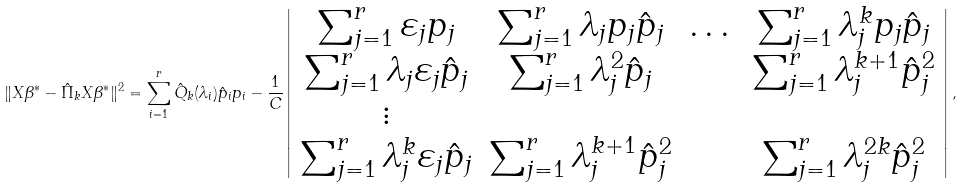<formula> <loc_0><loc_0><loc_500><loc_500>\| X \beta ^ { * } - \hat { \Pi } _ { k } X \beta ^ { * } \| ^ { 2 } = \sum _ { i = 1 } ^ { r } \hat { Q } _ { k } ( \lambda _ { i } ) \hat { p } _ { i } p _ { i } - \frac { 1 } { C } \left | \begin{array} { c c c c } \sum _ { j = 1 } ^ { r } \varepsilon _ { j } p _ { j } & \sum _ { j = 1 } ^ { r } \lambda _ { j } p _ { j } \hat { p } _ { j } & \dots & \sum _ { j = 1 } ^ { r } \lambda _ { j } ^ { k } p _ { j } \hat { p } _ { j } \\ \sum _ { j = 1 } ^ { r } \lambda _ { j } \varepsilon _ { j } \hat { p } _ { j } & \sum _ { j = 1 } ^ { r } \lambda _ { j } ^ { 2 } \hat { p } _ { j } & & \sum _ { j = 1 } ^ { r } \lambda _ { j } ^ { k + 1 } \hat { p } _ { j } ^ { 2 } \\ \vdots & & & \\ \sum _ { j = 1 } ^ { r } \lambda _ { j } ^ { k } \varepsilon _ { j } \hat { p } _ { j } & \sum _ { j = 1 } ^ { r } \lambda _ { j } ^ { k + 1 } \hat { p } _ { j } ^ { 2 } & & \sum _ { j = 1 } ^ { r } \lambda _ { j } ^ { 2 k } \hat { p } _ { j } ^ { 2 } \end{array} \right | ,</formula> 